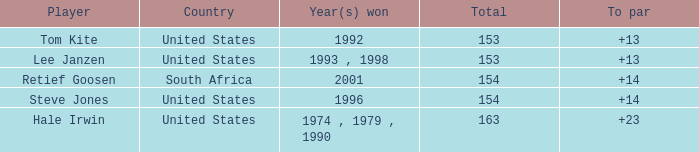When did the united states accomplish a to par of over 14? 1974 , 1979 , 1990. 